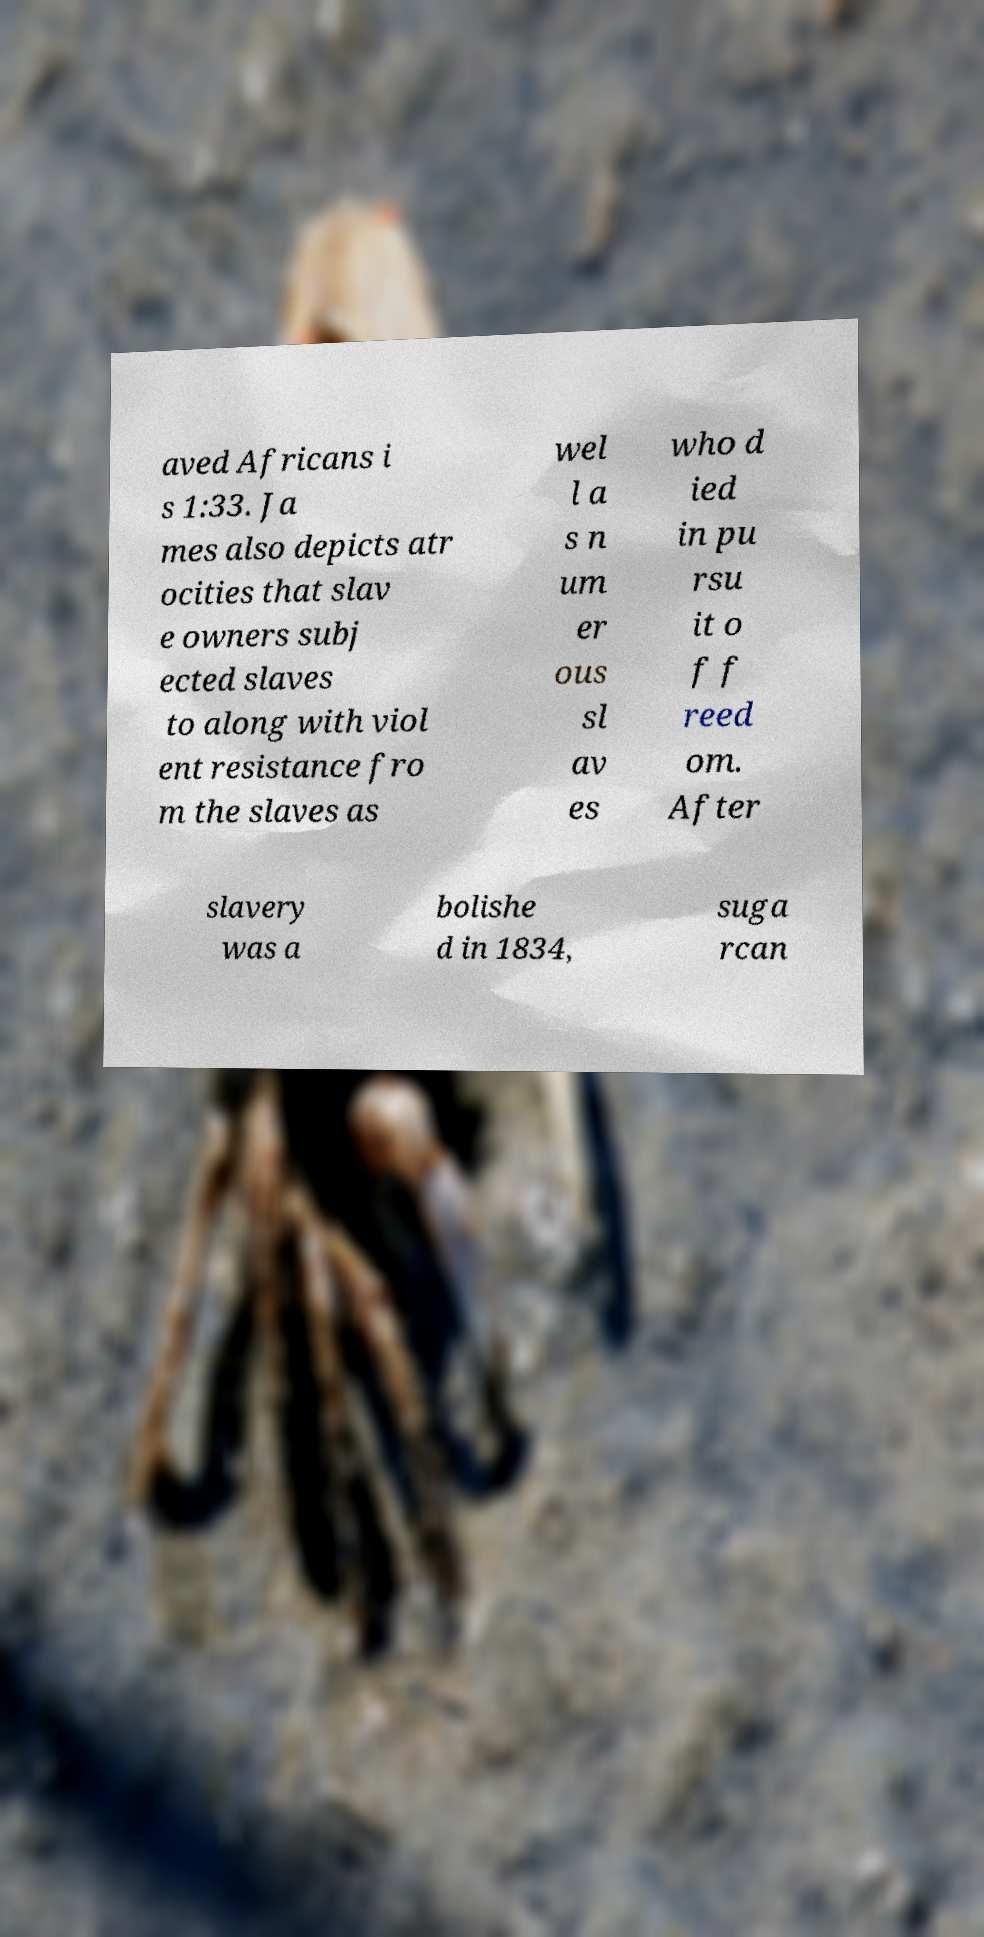For documentation purposes, I need the text within this image transcribed. Could you provide that? aved Africans i s 1:33. Ja mes also depicts atr ocities that slav e owners subj ected slaves to along with viol ent resistance fro m the slaves as wel l a s n um er ous sl av es who d ied in pu rsu it o f f reed om. After slavery was a bolishe d in 1834, suga rcan 